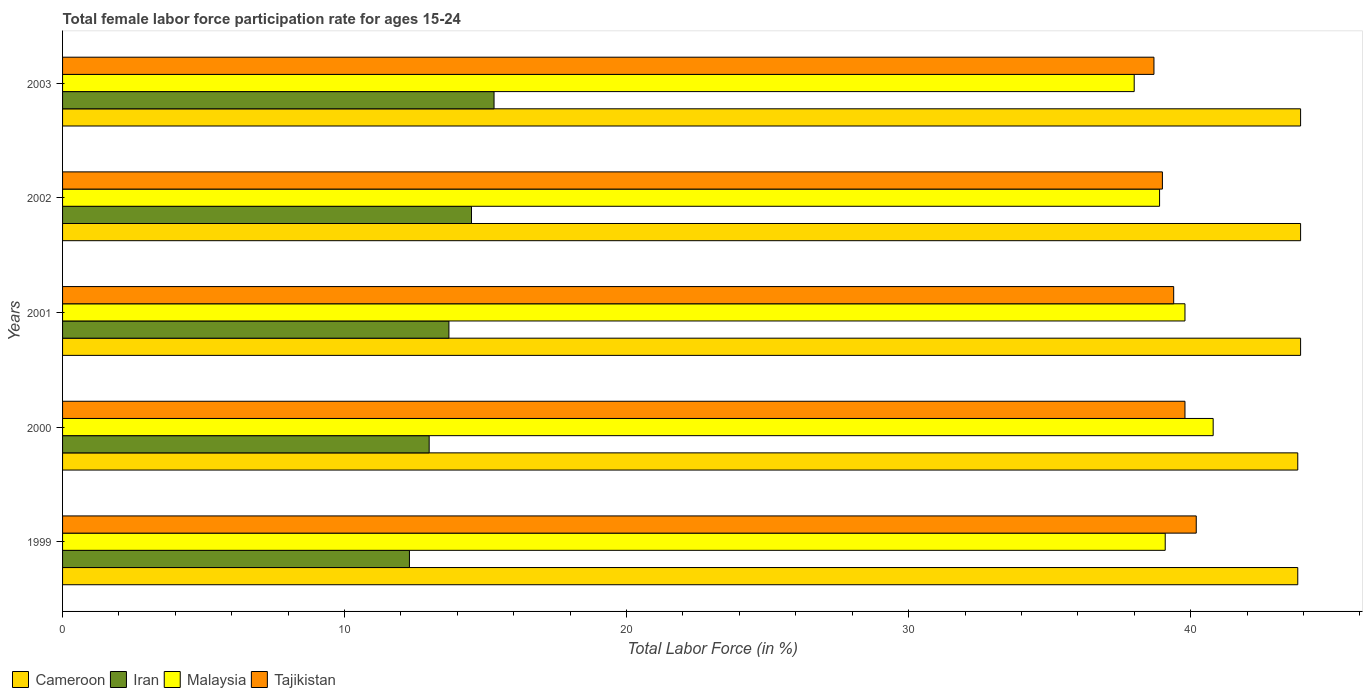Are the number of bars per tick equal to the number of legend labels?
Make the answer very short. Yes. What is the female labor force participation rate in Tajikistan in 2000?
Keep it short and to the point. 39.8. Across all years, what is the maximum female labor force participation rate in Malaysia?
Give a very brief answer. 40.8. Across all years, what is the minimum female labor force participation rate in Tajikistan?
Make the answer very short. 38.7. In which year was the female labor force participation rate in Cameroon minimum?
Your response must be concise. 1999. What is the total female labor force participation rate in Iran in the graph?
Offer a very short reply. 68.8. What is the difference between the female labor force participation rate in Tajikistan in 1999 and that in 2000?
Provide a succinct answer. 0.4. What is the difference between the female labor force participation rate in Iran in 1999 and the female labor force participation rate in Malaysia in 2003?
Give a very brief answer. -25.7. What is the average female labor force participation rate in Malaysia per year?
Your response must be concise. 39.32. In the year 2001, what is the difference between the female labor force participation rate in Malaysia and female labor force participation rate in Iran?
Your answer should be compact. 26.1. What is the ratio of the female labor force participation rate in Malaysia in 2000 to that in 2003?
Ensure brevity in your answer.  1.07. Is the female labor force participation rate in Tajikistan in 2001 less than that in 2003?
Your answer should be very brief. No. Is the difference between the female labor force participation rate in Malaysia in 1999 and 2002 greater than the difference between the female labor force participation rate in Iran in 1999 and 2002?
Offer a terse response. Yes. What is the difference between the highest and the second highest female labor force participation rate in Iran?
Give a very brief answer. 0.8. What is the difference between the highest and the lowest female labor force participation rate in Cameroon?
Give a very brief answer. 0.1. In how many years, is the female labor force participation rate in Iran greater than the average female labor force participation rate in Iran taken over all years?
Offer a terse response. 2. Is it the case that in every year, the sum of the female labor force participation rate in Cameroon and female labor force participation rate in Malaysia is greater than the sum of female labor force participation rate in Tajikistan and female labor force participation rate in Iran?
Give a very brief answer. Yes. What does the 4th bar from the top in 2001 represents?
Your answer should be compact. Cameroon. What does the 4th bar from the bottom in 2001 represents?
Your answer should be compact. Tajikistan. Is it the case that in every year, the sum of the female labor force participation rate in Iran and female labor force participation rate in Cameroon is greater than the female labor force participation rate in Malaysia?
Your answer should be compact. Yes. Are all the bars in the graph horizontal?
Ensure brevity in your answer.  Yes. Are the values on the major ticks of X-axis written in scientific E-notation?
Make the answer very short. No. Does the graph contain any zero values?
Make the answer very short. No. Where does the legend appear in the graph?
Make the answer very short. Bottom left. How many legend labels are there?
Offer a very short reply. 4. What is the title of the graph?
Make the answer very short. Total female labor force participation rate for ages 15-24. Does "Madagascar" appear as one of the legend labels in the graph?
Keep it short and to the point. No. What is the label or title of the X-axis?
Your response must be concise. Total Labor Force (in %). What is the Total Labor Force (in %) in Cameroon in 1999?
Keep it short and to the point. 43.8. What is the Total Labor Force (in %) of Iran in 1999?
Your answer should be very brief. 12.3. What is the Total Labor Force (in %) of Malaysia in 1999?
Offer a terse response. 39.1. What is the Total Labor Force (in %) of Tajikistan in 1999?
Offer a terse response. 40.2. What is the Total Labor Force (in %) in Cameroon in 2000?
Offer a very short reply. 43.8. What is the Total Labor Force (in %) of Malaysia in 2000?
Your response must be concise. 40.8. What is the Total Labor Force (in %) in Tajikistan in 2000?
Make the answer very short. 39.8. What is the Total Labor Force (in %) of Cameroon in 2001?
Offer a very short reply. 43.9. What is the Total Labor Force (in %) in Iran in 2001?
Provide a short and direct response. 13.7. What is the Total Labor Force (in %) in Malaysia in 2001?
Provide a short and direct response. 39.8. What is the Total Labor Force (in %) in Tajikistan in 2001?
Ensure brevity in your answer.  39.4. What is the Total Labor Force (in %) in Cameroon in 2002?
Offer a terse response. 43.9. What is the Total Labor Force (in %) in Iran in 2002?
Your answer should be very brief. 14.5. What is the Total Labor Force (in %) in Malaysia in 2002?
Offer a terse response. 38.9. What is the Total Labor Force (in %) of Cameroon in 2003?
Make the answer very short. 43.9. What is the Total Labor Force (in %) of Iran in 2003?
Offer a very short reply. 15.3. What is the Total Labor Force (in %) in Tajikistan in 2003?
Ensure brevity in your answer.  38.7. Across all years, what is the maximum Total Labor Force (in %) in Cameroon?
Offer a very short reply. 43.9. Across all years, what is the maximum Total Labor Force (in %) of Iran?
Keep it short and to the point. 15.3. Across all years, what is the maximum Total Labor Force (in %) of Malaysia?
Your response must be concise. 40.8. Across all years, what is the maximum Total Labor Force (in %) of Tajikistan?
Your answer should be very brief. 40.2. Across all years, what is the minimum Total Labor Force (in %) of Cameroon?
Keep it short and to the point. 43.8. Across all years, what is the minimum Total Labor Force (in %) of Iran?
Ensure brevity in your answer.  12.3. Across all years, what is the minimum Total Labor Force (in %) of Malaysia?
Offer a very short reply. 38. Across all years, what is the minimum Total Labor Force (in %) in Tajikistan?
Ensure brevity in your answer.  38.7. What is the total Total Labor Force (in %) of Cameroon in the graph?
Give a very brief answer. 219.3. What is the total Total Labor Force (in %) in Iran in the graph?
Your response must be concise. 68.8. What is the total Total Labor Force (in %) in Malaysia in the graph?
Offer a terse response. 196.6. What is the total Total Labor Force (in %) in Tajikistan in the graph?
Make the answer very short. 197.1. What is the difference between the Total Labor Force (in %) in Iran in 1999 and that in 2000?
Your response must be concise. -0.7. What is the difference between the Total Labor Force (in %) in Malaysia in 1999 and that in 2000?
Offer a very short reply. -1.7. What is the difference between the Total Labor Force (in %) in Malaysia in 1999 and that in 2001?
Ensure brevity in your answer.  -0.7. What is the difference between the Total Labor Force (in %) in Tajikistan in 1999 and that in 2001?
Offer a very short reply. 0.8. What is the difference between the Total Labor Force (in %) of Iran in 1999 and that in 2002?
Your response must be concise. -2.2. What is the difference between the Total Labor Force (in %) of Malaysia in 1999 and that in 2002?
Give a very brief answer. 0.2. What is the difference between the Total Labor Force (in %) of Cameroon in 1999 and that in 2003?
Provide a short and direct response. -0.1. What is the difference between the Total Labor Force (in %) of Iran in 1999 and that in 2003?
Provide a short and direct response. -3. What is the difference between the Total Labor Force (in %) of Malaysia in 1999 and that in 2003?
Give a very brief answer. 1.1. What is the difference between the Total Labor Force (in %) in Cameroon in 2000 and that in 2001?
Provide a succinct answer. -0.1. What is the difference between the Total Labor Force (in %) in Iran in 2000 and that in 2001?
Your answer should be very brief. -0.7. What is the difference between the Total Labor Force (in %) in Tajikistan in 2000 and that in 2001?
Ensure brevity in your answer.  0.4. What is the difference between the Total Labor Force (in %) in Iran in 2000 and that in 2002?
Your response must be concise. -1.5. What is the difference between the Total Labor Force (in %) in Malaysia in 2000 and that in 2002?
Offer a very short reply. 1.9. What is the difference between the Total Labor Force (in %) in Cameroon in 2000 and that in 2003?
Keep it short and to the point. -0.1. What is the difference between the Total Labor Force (in %) in Iran in 2001 and that in 2002?
Give a very brief answer. -0.8. What is the difference between the Total Labor Force (in %) of Cameroon in 2001 and that in 2003?
Your response must be concise. 0. What is the difference between the Total Labor Force (in %) of Iran in 2001 and that in 2003?
Offer a terse response. -1.6. What is the difference between the Total Labor Force (in %) of Iran in 2002 and that in 2003?
Offer a terse response. -0.8. What is the difference between the Total Labor Force (in %) in Cameroon in 1999 and the Total Labor Force (in %) in Iran in 2000?
Offer a terse response. 30.8. What is the difference between the Total Labor Force (in %) of Cameroon in 1999 and the Total Labor Force (in %) of Malaysia in 2000?
Make the answer very short. 3. What is the difference between the Total Labor Force (in %) of Cameroon in 1999 and the Total Labor Force (in %) of Tajikistan in 2000?
Offer a very short reply. 4. What is the difference between the Total Labor Force (in %) in Iran in 1999 and the Total Labor Force (in %) in Malaysia in 2000?
Offer a very short reply. -28.5. What is the difference between the Total Labor Force (in %) in Iran in 1999 and the Total Labor Force (in %) in Tajikistan in 2000?
Keep it short and to the point. -27.5. What is the difference between the Total Labor Force (in %) of Malaysia in 1999 and the Total Labor Force (in %) of Tajikistan in 2000?
Your answer should be very brief. -0.7. What is the difference between the Total Labor Force (in %) of Cameroon in 1999 and the Total Labor Force (in %) of Iran in 2001?
Provide a succinct answer. 30.1. What is the difference between the Total Labor Force (in %) in Cameroon in 1999 and the Total Labor Force (in %) in Malaysia in 2001?
Offer a terse response. 4. What is the difference between the Total Labor Force (in %) of Cameroon in 1999 and the Total Labor Force (in %) of Tajikistan in 2001?
Keep it short and to the point. 4.4. What is the difference between the Total Labor Force (in %) in Iran in 1999 and the Total Labor Force (in %) in Malaysia in 2001?
Your answer should be very brief. -27.5. What is the difference between the Total Labor Force (in %) in Iran in 1999 and the Total Labor Force (in %) in Tajikistan in 2001?
Make the answer very short. -27.1. What is the difference between the Total Labor Force (in %) in Malaysia in 1999 and the Total Labor Force (in %) in Tajikistan in 2001?
Keep it short and to the point. -0.3. What is the difference between the Total Labor Force (in %) in Cameroon in 1999 and the Total Labor Force (in %) in Iran in 2002?
Your response must be concise. 29.3. What is the difference between the Total Labor Force (in %) in Cameroon in 1999 and the Total Labor Force (in %) in Tajikistan in 2002?
Your response must be concise. 4.8. What is the difference between the Total Labor Force (in %) in Iran in 1999 and the Total Labor Force (in %) in Malaysia in 2002?
Provide a succinct answer. -26.6. What is the difference between the Total Labor Force (in %) of Iran in 1999 and the Total Labor Force (in %) of Tajikistan in 2002?
Your response must be concise. -26.7. What is the difference between the Total Labor Force (in %) in Cameroon in 1999 and the Total Labor Force (in %) in Iran in 2003?
Offer a very short reply. 28.5. What is the difference between the Total Labor Force (in %) of Cameroon in 1999 and the Total Labor Force (in %) of Tajikistan in 2003?
Offer a terse response. 5.1. What is the difference between the Total Labor Force (in %) of Iran in 1999 and the Total Labor Force (in %) of Malaysia in 2003?
Keep it short and to the point. -25.7. What is the difference between the Total Labor Force (in %) of Iran in 1999 and the Total Labor Force (in %) of Tajikistan in 2003?
Keep it short and to the point. -26.4. What is the difference between the Total Labor Force (in %) of Cameroon in 2000 and the Total Labor Force (in %) of Iran in 2001?
Make the answer very short. 30.1. What is the difference between the Total Labor Force (in %) in Cameroon in 2000 and the Total Labor Force (in %) in Malaysia in 2001?
Your answer should be compact. 4. What is the difference between the Total Labor Force (in %) in Cameroon in 2000 and the Total Labor Force (in %) in Tajikistan in 2001?
Your answer should be very brief. 4.4. What is the difference between the Total Labor Force (in %) of Iran in 2000 and the Total Labor Force (in %) of Malaysia in 2001?
Offer a very short reply. -26.8. What is the difference between the Total Labor Force (in %) in Iran in 2000 and the Total Labor Force (in %) in Tajikistan in 2001?
Your response must be concise. -26.4. What is the difference between the Total Labor Force (in %) in Cameroon in 2000 and the Total Labor Force (in %) in Iran in 2002?
Keep it short and to the point. 29.3. What is the difference between the Total Labor Force (in %) of Cameroon in 2000 and the Total Labor Force (in %) of Malaysia in 2002?
Give a very brief answer. 4.9. What is the difference between the Total Labor Force (in %) in Cameroon in 2000 and the Total Labor Force (in %) in Tajikistan in 2002?
Your answer should be compact. 4.8. What is the difference between the Total Labor Force (in %) of Iran in 2000 and the Total Labor Force (in %) of Malaysia in 2002?
Your response must be concise. -25.9. What is the difference between the Total Labor Force (in %) in Cameroon in 2000 and the Total Labor Force (in %) in Malaysia in 2003?
Your answer should be compact. 5.8. What is the difference between the Total Labor Force (in %) of Cameroon in 2000 and the Total Labor Force (in %) of Tajikistan in 2003?
Keep it short and to the point. 5.1. What is the difference between the Total Labor Force (in %) of Iran in 2000 and the Total Labor Force (in %) of Tajikistan in 2003?
Your answer should be compact. -25.7. What is the difference between the Total Labor Force (in %) of Cameroon in 2001 and the Total Labor Force (in %) of Iran in 2002?
Your answer should be very brief. 29.4. What is the difference between the Total Labor Force (in %) of Iran in 2001 and the Total Labor Force (in %) of Malaysia in 2002?
Make the answer very short. -25.2. What is the difference between the Total Labor Force (in %) of Iran in 2001 and the Total Labor Force (in %) of Tajikistan in 2002?
Your answer should be very brief. -25.3. What is the difference between the Total Labor Force (in %) of Cameroon in 2001 and the Total Labor Force (in %) of Iran in 2003?
Your answer should be compact. 28.6. What is the difference between the Total Labor Force (in %) in Iran in 2001 and the Total Labor Force (in %) in Malaysia in 2003?
Your answer should be very brief. -24.3. What is the difference between the Total Labor Force (in %) of Iran in 2001 and the Total Labor Force (in %) of Tajikistan in 2003?
Offer a terse response. -25. What is the difference between the Total Labor Force (in %) in Cameroon in 2002 and the Total Labor Force (in %) in Iran in 2003?
Your answer should be compact. 28.6. What is the difference between the Total Labor Force (in %) in Cameroon in 2002 and the Total Labor Force (in %) in Tajikistan in 2003?
Provide a short and direct response. 5.2. What is the difference between the Total Labor Force (in %) of Iran in 2002 and the Total Labor Force (in %) of Malaysia in 2003?
Ensure brevity in your answer.  -23.5. What is the difference between the Total Labor Force (in %) in Iran in 2002 and the Total Labor Force (in %) in Tajikistan in 2003?
Keep it short and to the point. -24.2. What is the average Total Labor Force (in %) of Cameroon per year?
Offer a terse response. 43.86. What is the average Total Labor Force (in %) in Iran per year?
Provide a succinct answer. 13.76. What is the average Total Labor Force (in %) of Malaysia per year?
Your response must be concise. 39.32. What is the average Total Labor Force (in %) in Tajikistan per year?
Make the answer very short. 39.42. In the year 1999, what is the difference between the Total Labor Force (in %) of Cameroon and Total Labor Force (in %) of Iran?
Ensure brevity in your answer.  31.5. In the year 1999, what is the difference between the Total Labor Force (in %) in Iran and Total Labor Force (in %) in Malaysia?
Keep it short and to the point. -26.8. In the year 1999, what is the difference between the Total Labor Force (in %) of Iran and Total Labor Force (in %) of Tajikistan?
Keep it short and to the point. -27.9. In the year 1999, what is the difference between the Total Labor Force (in %) of Malaysia and Total Labor Force (in %) of Tajikistan?
Keep it short and to the point. -1.1. In the year 2000, what is the difference between the Total Labor Force (in %) of Cameroon and Total Labor Force (in %) of Iran?
Keep it short and to the point. 30.8. In the year 2000, what is the difference between the Total Labor Force (in %) of Cameroon and Total Labor Force (in %) of Malaysia?
Your response must be concise. 3. In the year 2000, what is the difference between the Total Labor Force (in %) of Cameroon and Total Labor Force (in %) of Tajikistan?
Give a very brief answer. 4. In the year 2000, what is the difference between the Total Labor Force (in %) in Iran and Total Labor Force (in %) in Malaysia?
Make the answer very short. -27.8. In the year 2000, what is the difference between the Total Labor Force (in %) of Iran and Total Labor Force (in %) of Tajikistan?
Keep it short and to the point. -26.8. In the year 2000, what is the difference between the Total Labor Force (in %) of Malaysia and Total Labor Force (in %) of Tajikistan?
Your answer should be compact. 1. In the year 2001, what is the difference between the Total Labor Force (in %) of Cameroon and Total Labor Force (in %) of Iran?
Offer a terse response. 30.2. In the year 2001, what is the difference between the Total Labor Force (in %) in Cameroon and Total Labor Force (in %) in Tajikistan?
Your answer should be very brief. 4.5. In the year 2001, what is the difference between the Total Labor Force (in %) in Iran and Total Labor Force (in %) in Malaysia?
Give a very brief answer. -26.1. In the year 2001, what is the difference between the Total Labor Force (in %) in Iran and Total Labor Force (in %) in Tajikistan?
Offer a terse response. -25.7. In the year 2002, what is the difference between the Total Labor Force (in %) of Cameroon and Total Labor Force (in %) of Iran?
Provide a short and direct response. 29.4. In the year 2002, what is the difference between the Total Labor Force (in %) in Cameroon and Total Labor Force (in %) in Tajikistan?
Offer a very short reply. 4.9. In the year 2002, what is the difference between the Total Labor Force (in %) in Iran and Total Labor Force (in %) in Malaysia?
Give a very brief answer. -24.4. In the year 2002, what is the difference between the Total Labor Force (in %) in Iran and Total Labor Force (in %) in Tajikistan?
Give a very brief answer. -24.5. In the year 2002, what is the difference between the Total Labor Force (in %) in Malaysia and Total Labor Force (in %) in Tajikistan?
Your response must be concise. -0.1. In the year 2003, what is the difference between the Total Labor Force (in %) in Cameroon and Total Labor Force (in %) in Iran?
Your answer should be compact. 28.6. In the year 2003, what is the difference between the Total Labor Force (in %) of Cameroon and Total Labor Force (in %) of Malaysia?
Offer a terse response. 5.9. In the year 2003, what is the difference between the Total Labor Force (in %) of Cameroon and Total Labor Force (in %) of Tajikistan?
Your response must be concise. 5.2. In the year 2003, what is the difference between the Total Labor Force (in %) in Iran and Total Labor Force (in %) in Malaysia?
Provide a short and direct response. -22.7. In the year 2003, what is the difference between the Total Labor Force (in %) in Iran and Total Labor Force (in %) in Tajikistan?
Make the answer very short. -23.4. In the year 2003, what is the difference between the Total Labor Force (in %) in Malaysia and Total Labor Force (in %) in Tajikistan?
Provide a short and direct response. -0.7. What is the ratio of the Total Labor Force (in %) in Iran in 1999 to that in 2000?
Your answer should be compact. 0.95. What is the ratio of the Total Labor Force (in %) of Malaysia in 1999 to that in 2000?
Make the answer very short. 0.96. What is the ratio of the Total Labor Force (in %) of Tajikistan in 1999 to that in 2000?
Make the answer very short. 1.01. What is the ratio of the Total Labor Force (in %) of Cameroon in 1999 to that in 2001?
Keep it short and to the point. 1. What is the ratio of the Total Labor Force (in %) in Iran in 1999 to that in 2001?
Keep it short and to the point. 0.9. What is the ratio of the Total Labor Force (in %) of Malaysia in 1999 to that in 2001?
Provide a short and direct response. 0.98. What is the ratio of the Total Labor Force (in %) of Tajikistan in 1999 to that in 2001?
Ensure brevity in your answer.  1.02. What is the ratio of the Total Labor Force (in %) in Iran in 1999 to that in 2002?
Keep it short and to the point. 0.85. What is the ratio of the Total Labor Force (in %) of Tajikistan in 1999 to that in 2002?
Ensure brevity in your answer.  1.03. What is the ratio of the Total Labor Force (in %) of Iran in 1999 to that in 2003?
Offer a very short reply. 0.8. What is the ratio of the Total Labor Force (in %) in Malaysia in 1999 to that in 2003?
Offer a very short reply. 1.03. What is the ratio of the Total Labor Force (in %) of Tajikistan in 1999 to that in 2003?
Provide a short and direct response. 1.04. What is the ratio of the Total Labor Force (in %) in Cameroon in 2000 to that in 2001?
Make the answer very short. 1. What is the ratio of the Total Labor Force (in %) in Iran in 2000 to that in 2001?
Your answer should be very brief. 0.95. What is the ratio of the Total Labor Force (in %) of Malaysia in 2000 to that in 2001?
Make the answer very short. 1.03. What is the ratio of the Total Labor Force (in %) of Tajikistan in 2000 to that in 2001?
Keep it short and to the point. 1.01. What is the ratio of the Total Labor Force (in %) of Iran in 2000 to that in 2002?
Offer a very short reply. 0.9. What is the ratio of the Total Labor Force (in %) in Malaysia in 2000 to that in 2002?
Your response must be concise. 1.05. What is the ratio of the Total Labor Force (in %) of Tajikistan in 2000 to that in 2002?
Your answer should be very brief. 1.02. What is the ratio of the Total Labor Force (in %) of Iran in 2000 to that in 2003?
Make the answer very short. 0.85. What is the ratio of the Total Labor Force (in %) of Malaysia in 2000 to that in 2003?
Ensure brevity in your answer.  1.07. What is the ratio of the Total Labor Force (in %) of Tajikistan in 2000 to that in 2003?
Provide a succinct answer. 1.03. What is the ratio of the Total Labor Force (in %) in Iran in 2001 to that in 2002?
Ensure brevity in your answer.  0.94. What is the ratio of the Total Labor Force (in %) in Malaysia in 2001 to that in 2002?
Ensure brevity in your answer.  1.02. What is the ratio of the Total Labor Force (in %) of Tajikistan in 2001 to that in 2002?
Provide a short and direct response. 1.01. What is the ratio of the Total Labor Force (in %) in Iran in 2001 to that in 2003?
Give a very brief answer. 0.9. What is the ratio of the Total Labor Force (in %) of Malaysia in 2001 to that in 2003?
Your response must be concise. 1.05. What is the ratio of the Total Labor Force (in %) of Tajikistan in 2001 to that in 2003?
Ensure brevity in your answer.  1.02. What is the ratio of the Total Labor Force (in %) of Iran in 2002 to that in 2003?
Your answer should be very brief. 0.95. What is the ratio of the Total Labor Force (in %) in Malaysia in 2002 to that in 2003?
Give a very brief answer. 1.02. What is the difference between the highest and the second highest Total Labor Force (in %) in Malaysia?
Give a very brief answer. 1. What is the difference between the highest and the second highest Total Labor Force (in %) of Tajikistan?
Ensure brevity in your answer.  0.4. What is the difference between the highest and the lowest Total Labor Force (in %) of Malaysia?
Ensure brevity in your answer.  2.8. 